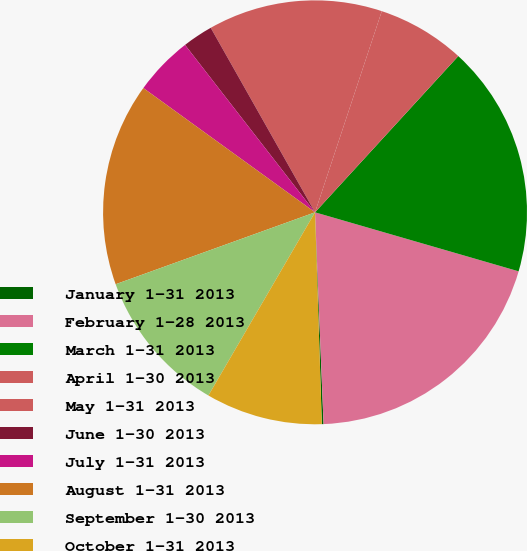Convert chart. <chart><loc_0><loc_0><loc_500><loc_500><pie_chart><fcel>January 1-31 2013<fcel>February 1-28 2013<fcel>March 1-31 2013<fcel>April 1-30 2013<fcel>May 1-31 2013<fcel>June 1-30 2013<fcel>July 1-31 2013<fcel>August 1-31 2013<fcel>September 1-30 2013<fcel>October 1-31 2013<nl><fcel>0.13%<fcel>19.87%<fcel>17.68%<fcel>6.71%<fcel>13.29%<fcel>2.32%<fcel>4.52%<fcel>15.48%<fcel>11.1%<fcel>8.9%<nl></chart> 